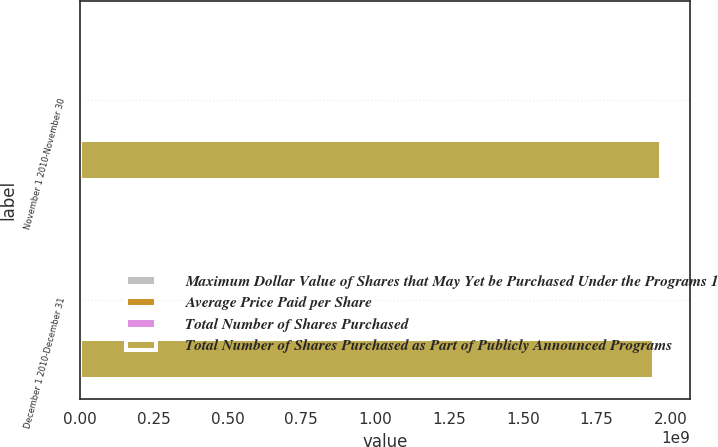<chart> <loc_0><loc_0><loc_500><loc_500><stacked_bar_chart><ecel><fcel>November 1 2010-November 30<fcel>December 1 2010-December 31<nl><fcel>Maximum Dollar Value of Shares that May Yet be Purchased Under the Programs 1<fcel>1.29013e+07<fcel>798676<nl><fcel>Average Price Paid per Share<fcel>30.18<fcel>29.68<nl><fcel>Total Number of Shares Purchased<fcel>1.29013e+07<fcel>798676<nl><fcel>Total Number of Shares Purchased as Part of Publicly Announced Programs<fcel>1.96741e+09<fcel>1.94371e+09<nl></chart> 